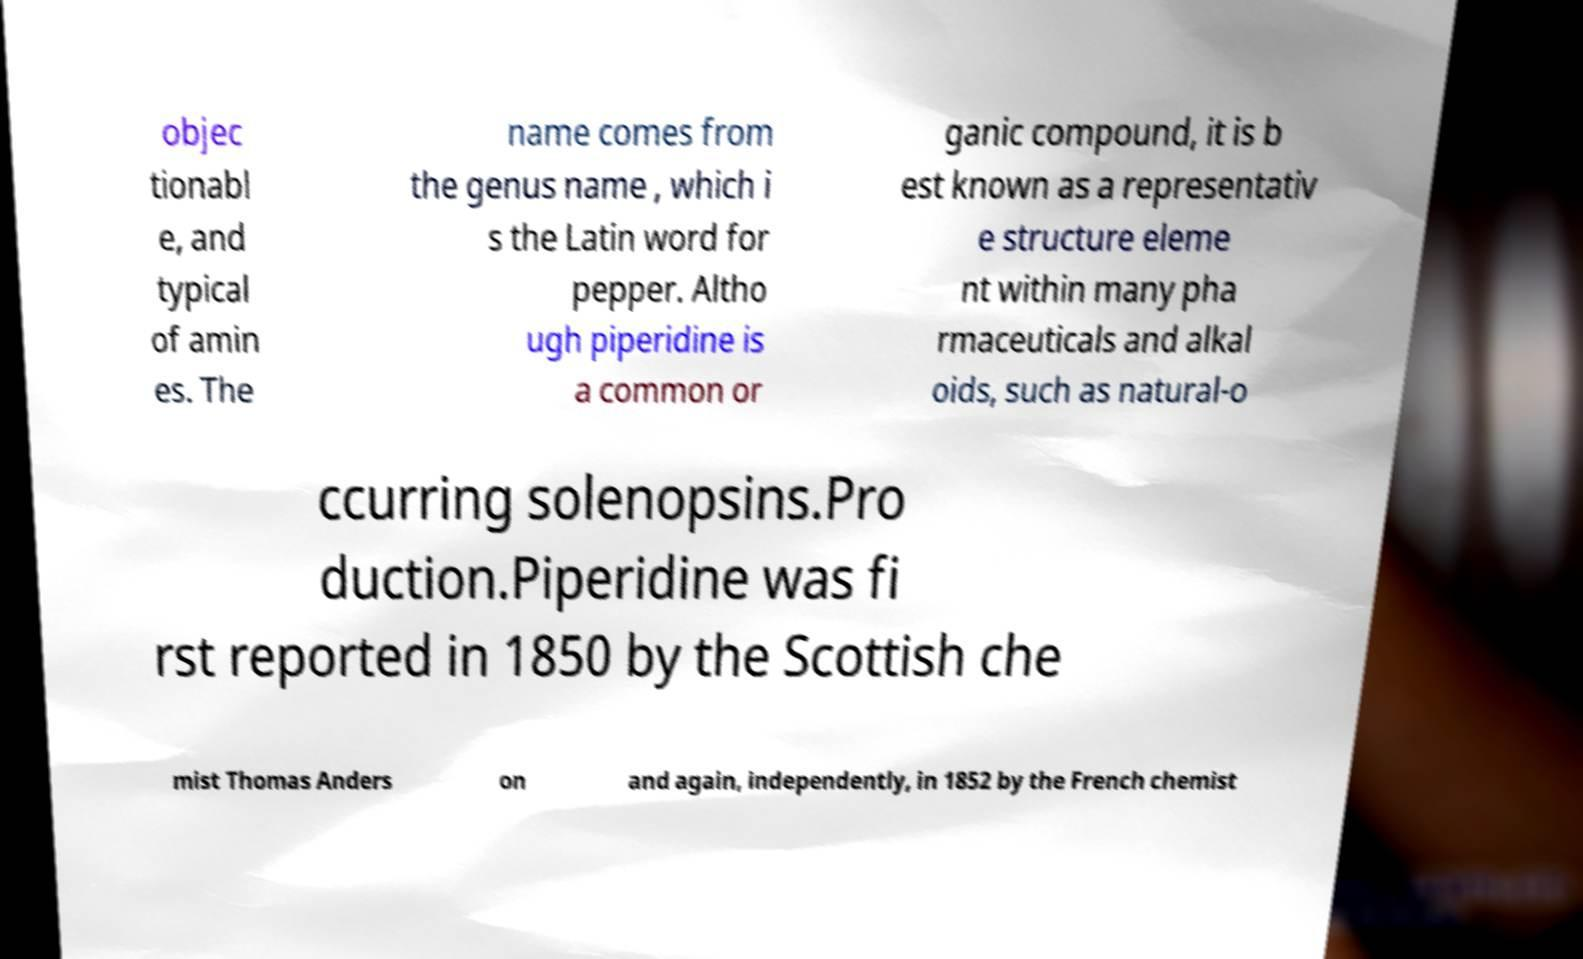Please read and relay the text visible in this image. What does it say? objec tionabl e, and typical of amin es. The name comes from the genus name , which i s the Latin word for pepper. Altho ugh piperidine is a common or ganic compound, it is b est known as a representativ e structure eleme nt within many pha rmaceuticals and alkal oids, such as natural-o ccurring solenopsins.Pro duction.Piperidine was fi rst reported in 1850 by the Scottish che mist Thomas Anders on and again, independently, in 1852 by the French chemist 